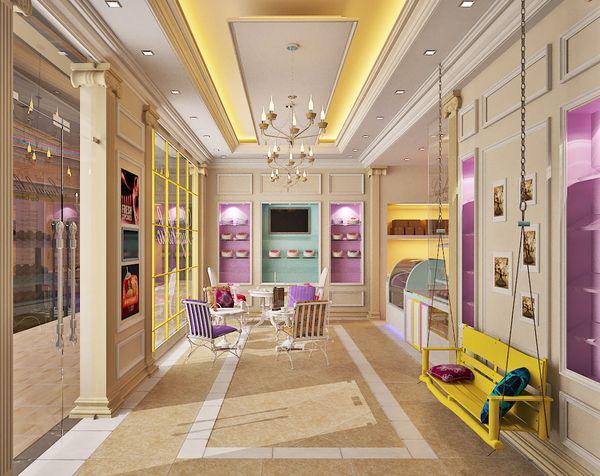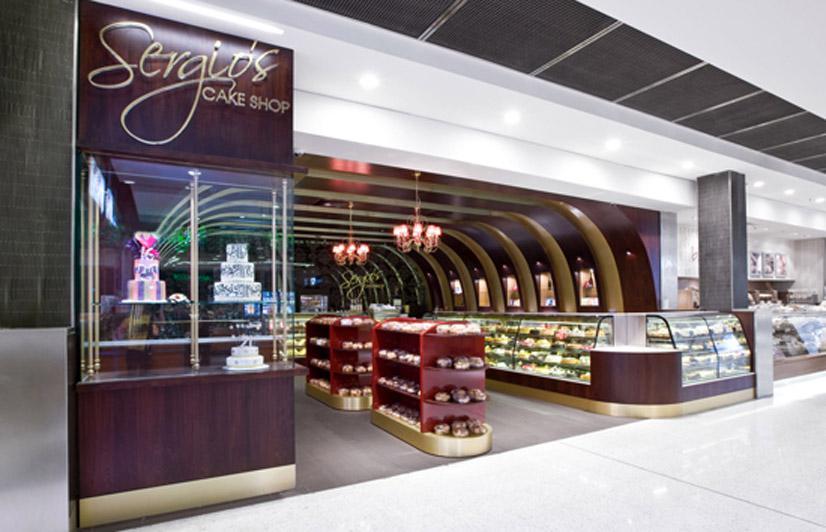The first image is the image on the left, the second image is the image on the right. For the images displayed, is the sentence "A bakery in one image has an indoor seating area for customers." factually correct? Answer yes or no. Yes. 